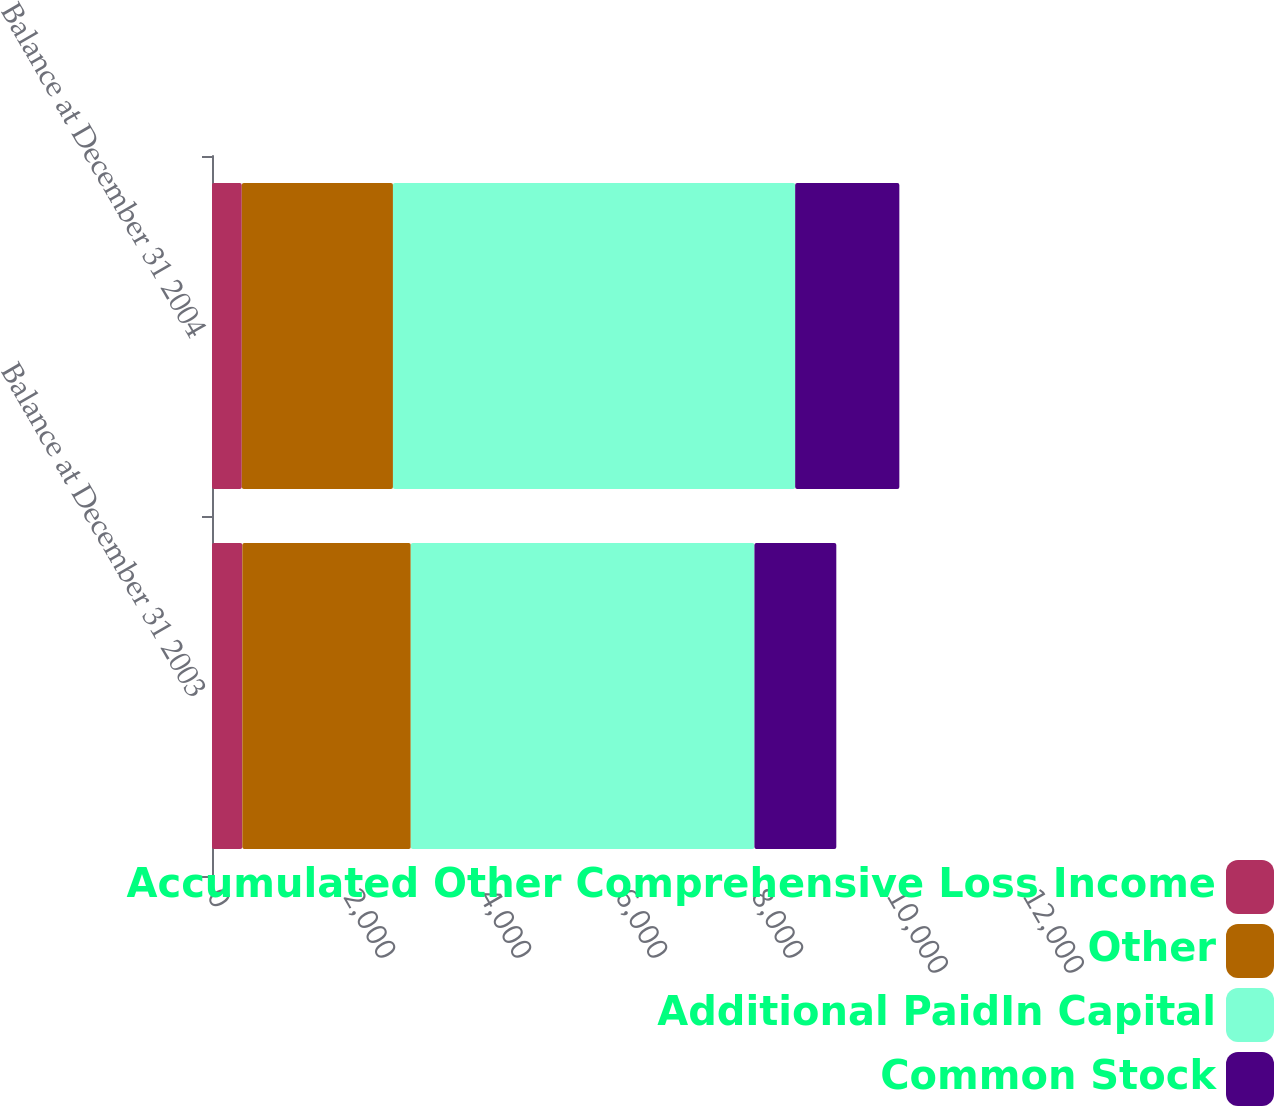<chart> <loc_0><loc_0><loc_500><loc_500><stacked_bar_chart><ecel><fcel>Balance at December 31 2003<fcel>Balance at December 31 2004<nl><fcel>Accumulated Other Comprehensive Loss Income<fcel>446<fcel>438<nl><fcel>Other<fcel>2477<fcel>2223<nl><fcel>Additional PaidIn Capital<fcel>5054<fcel>5915<nl><fcel>Common Stock<fcel>1204<fcel>1532<nl></chart> 